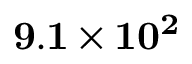<formula> <loc_0><loc_0><loc_500><loc_500>9 . 1 \times 1 0 ^ { 2 }</formula> 